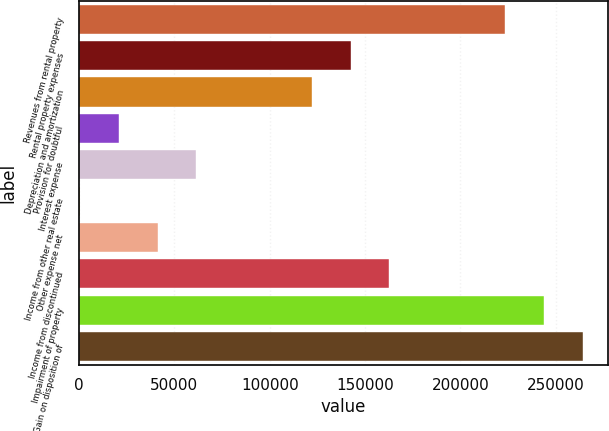Convert chart to OTSL. <chart><loc_0><loc_0><loc_500><loc_500><bar_chart><fcel>Revenues from rental property<fcel>Rental property expenses<fcel>Depreciation and amortization<fcel>Provision for doubtful<fcel>Interest expense<fcel>Income from other real estate<fcel>Other expense net<fcel>Income from discontinued<fcel>Impairment of property<fcel>Gain on disposition of<nl><fcel>223530<fcel>142494<fcel>122235<fcel>20939.1<fcel>61457.3<fcel>680<fcel>41198.2<fcel>162753<fcel>243789<fcel>264048<nl></chart> 